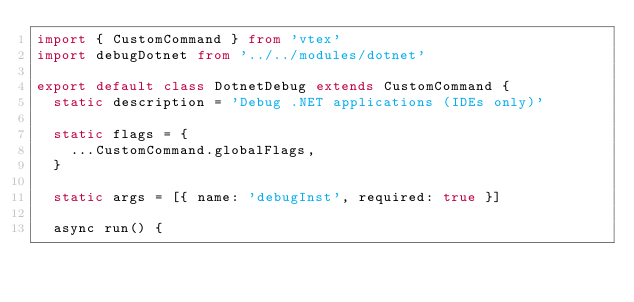<code> <loc_0><loc_0><loc_500><loc_500><_TypeScript_>import { CustomCommand } from 'vtex'
import debugDotnet from '../../modules/dotnet'

export default class DotnetDebug extends CustomCommand {
  static description = 'Debug .NET applications (IDEs only)'

  static flags = {
    ...CustomCommand.globalFlags,
  }

  static args = [{ name: 'debugInst', required: true }]

  async run() {</code> 